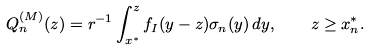Convert formula to latex. <formula><loc_0><loc_0><loc_500><loc_500>Q ^ { ( M ) } _ { n } ( z ) = r ^ { - 1 } \int _ { x ^ { * } } ^ { z } f _ { I } ( y - z ) \sigma _ { n } ( y ) \, d y , \quad z \geq x ^ { * } _ { n } .</formula> 